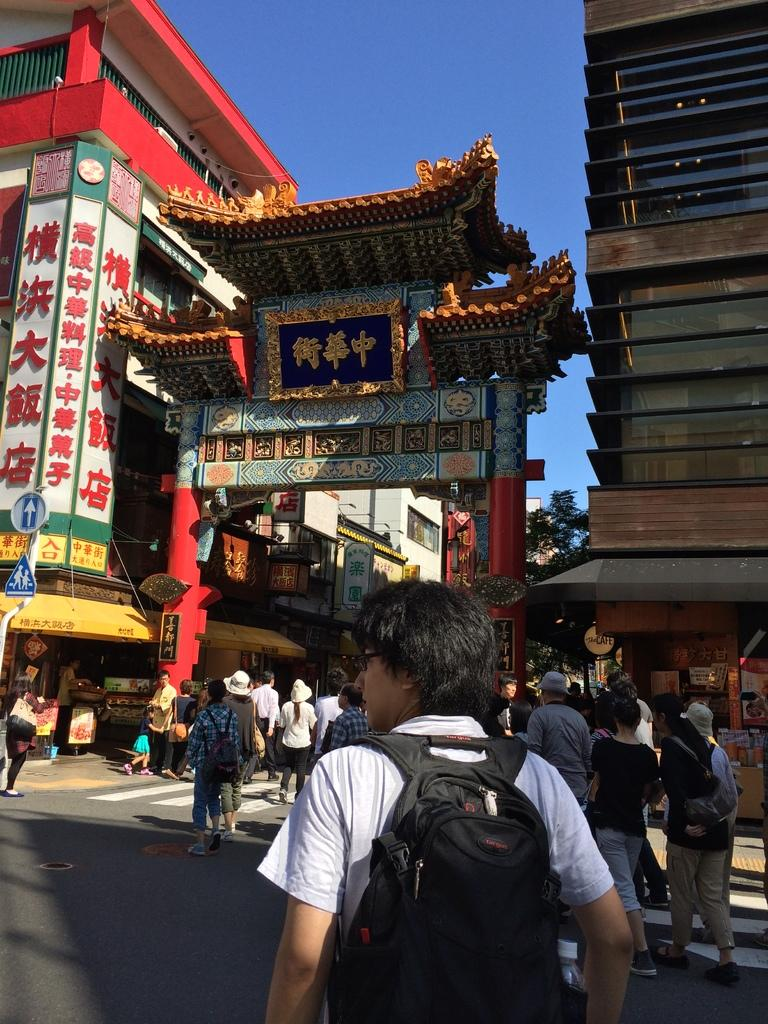Who is present in the image? There is a man in the image. What is the man carrying on his shoulder? The man is carrying a bag on his shoulder. What can be seen in the background of the image? There are people walking, buildings, an arch, hoardings, lights, a sign board, poles, and the sky visible in the background. Can you see any bread being sold near the river in the image? There is no river or bread being sold present in the image. 